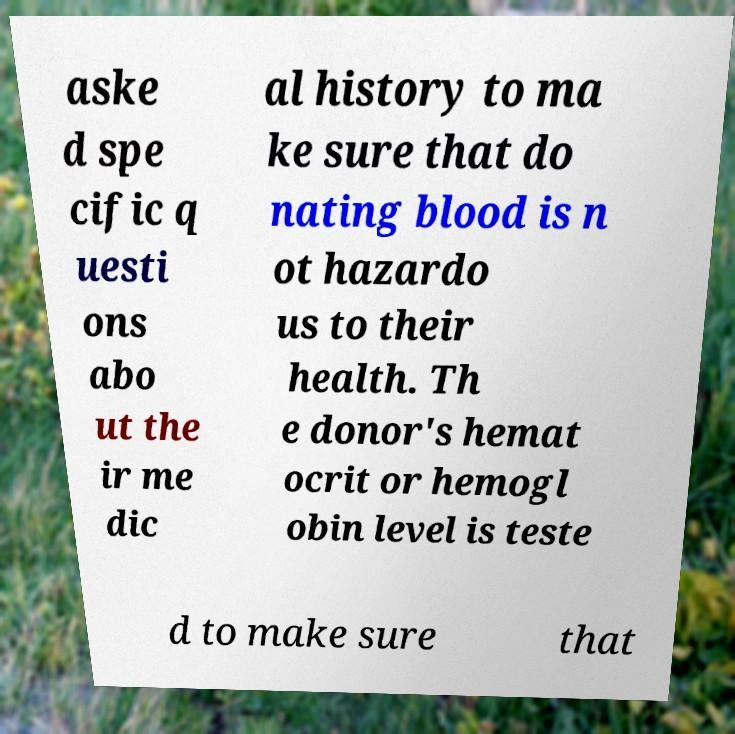I need the written content from this picture converted into text. Can you do that? aske d spe cific q uesti ons abo ut the ir me dic al history to ma ke sure that do nating blood is n ot hazardo us to their health. Th e donor's hemat ocrit or hemogl obin level is teste d to make sure that 